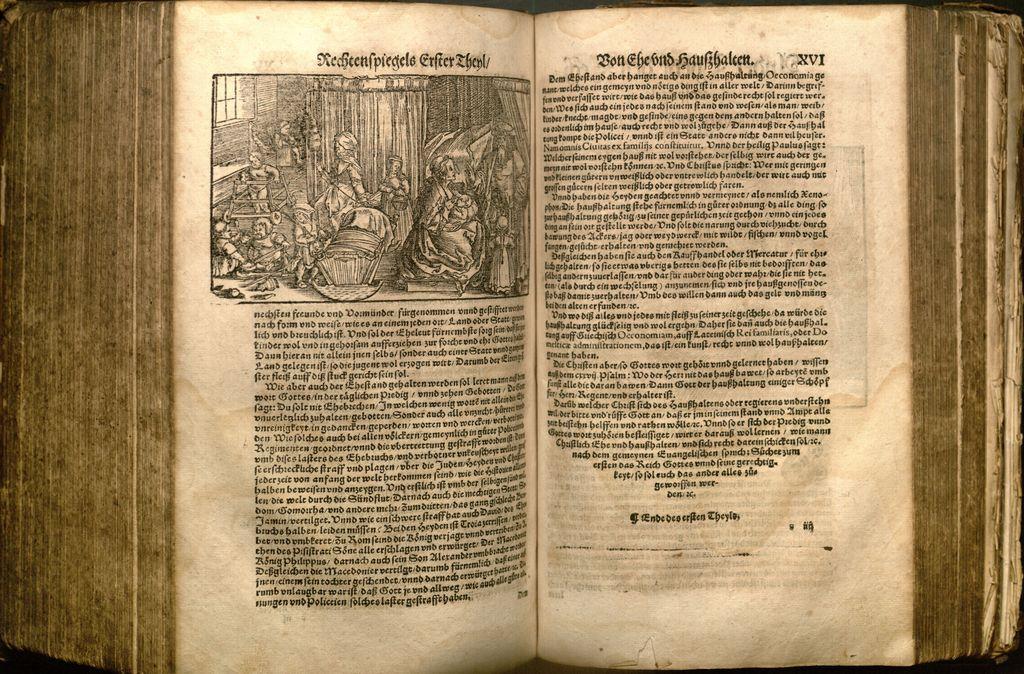Is this in english?
Your answer should be very brief. No. 